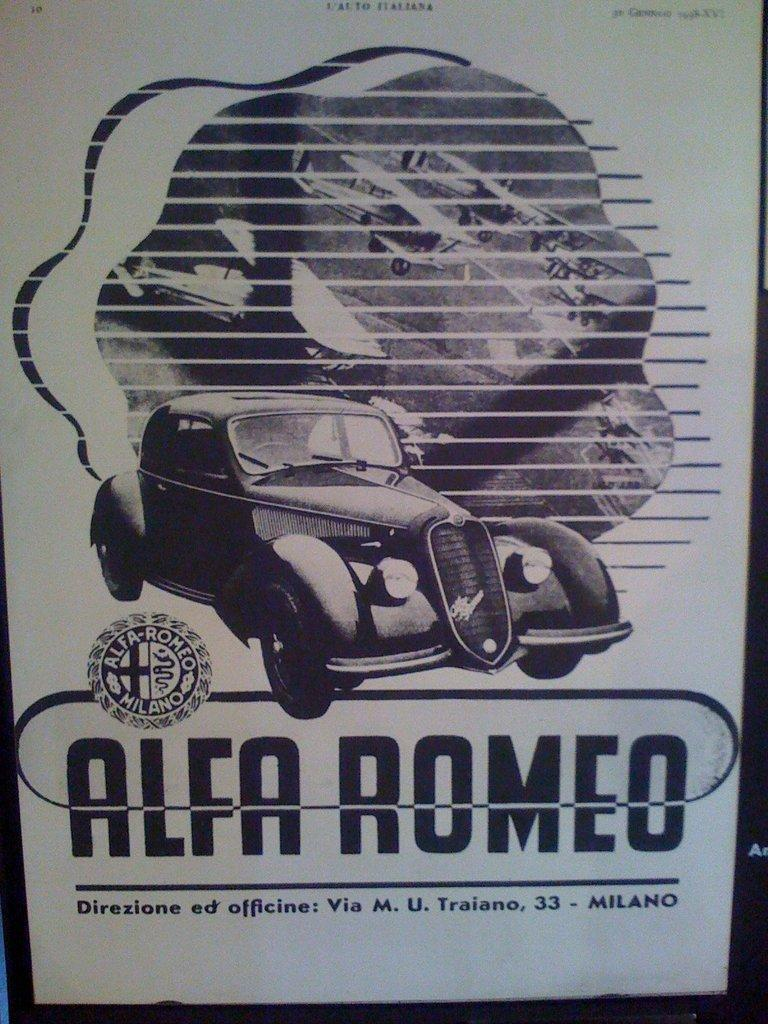What is the main subject of the image? The main subject of the image is a car. What else can be seen in the image besides the car? There is text and a logo in the image. Are there any other vehicles or objects in the image? Yes, there are aircraft in the image. How many legs does the car have in the image? Cars do not have legs; they have wheels. In the image, the car has four wheels. 